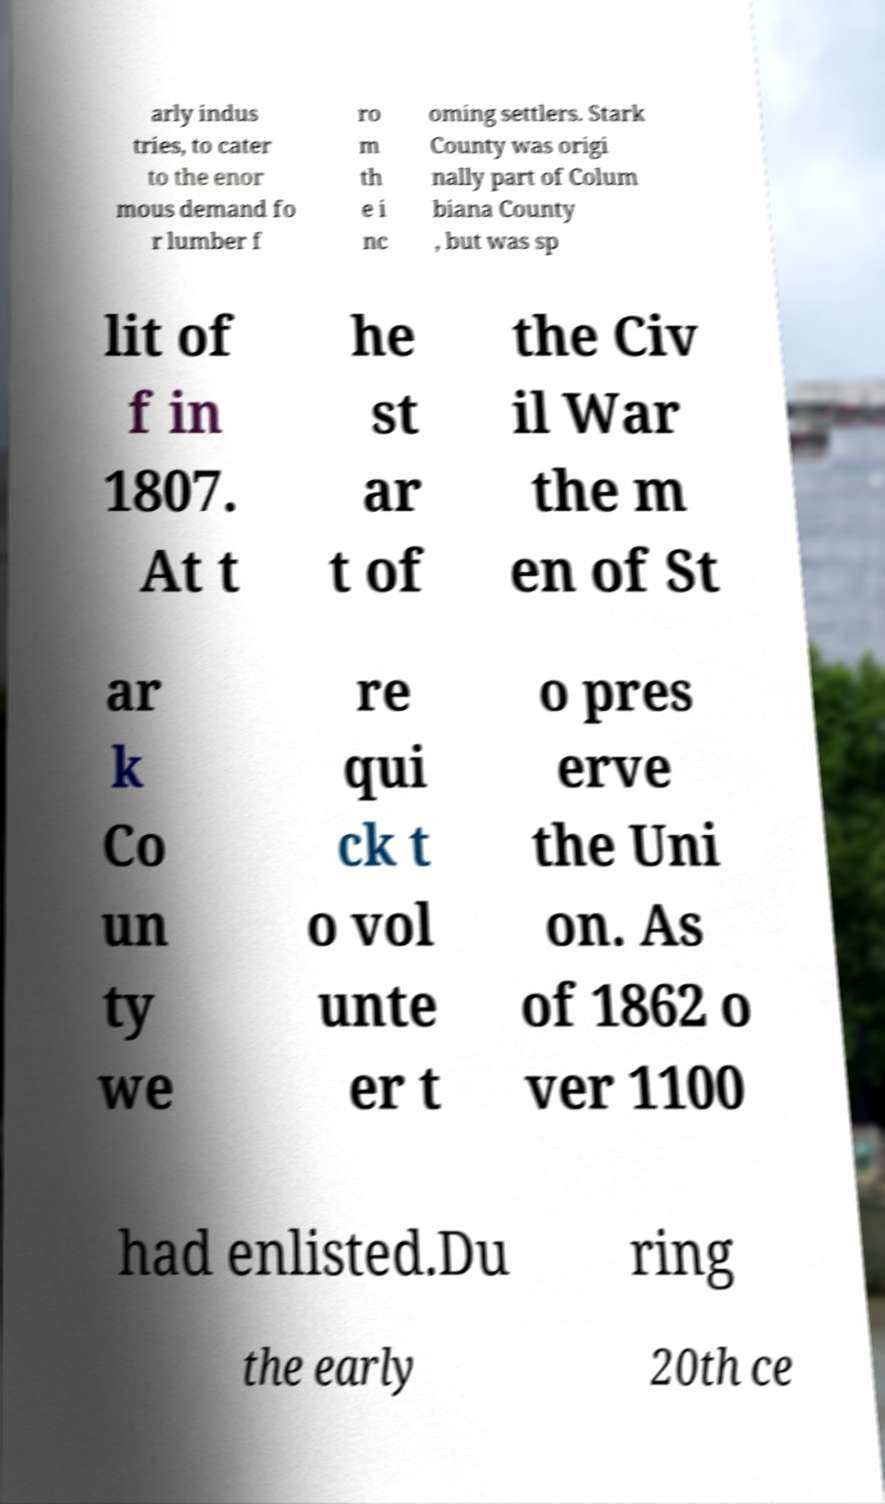Can you accurately transcribe the text from the provided image for me? arly indus tries, to cater to the enor mous demand fo r lumber f ro m th e i nc oming settlers. Stark County was origi nally part of Colum biana County , but was sp lit of f in 1807. At t he st ar t of the Civ il War the m en of St ar k Co un ty we re qui ck t o vol unte er t o pres erve the Uni on. As of 1862 o ver 1100 had enlisted.Du ring the early 20th ce 